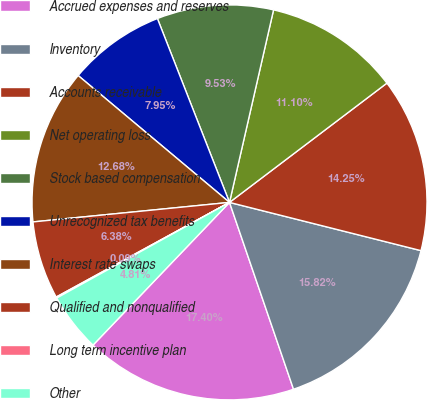Convert chart. <chart><loc_0><loc_0><loc_500><loc_500><pie_chart><fcel>Accrued expenses and reserves<fcel>Inventory<fcel>Accounts receivable<fcel>Net operating loss<fcel>Stock based compensation<fcel>Unrecognized tax benefits<fcel>Interest rate swaps<fcel>Qualified and nonqualified<fcel>Long term incentive plan<fcel>Other<nl><fcel>17.4%<fcel>15.82%<fcel>14.25%<fcel>11.1%<fcel>9.53%<fcel>7.95%<fcel>12.68%<fcel>6.38%<fcel>0.09%<fcel>4.81%<nl></chart> 